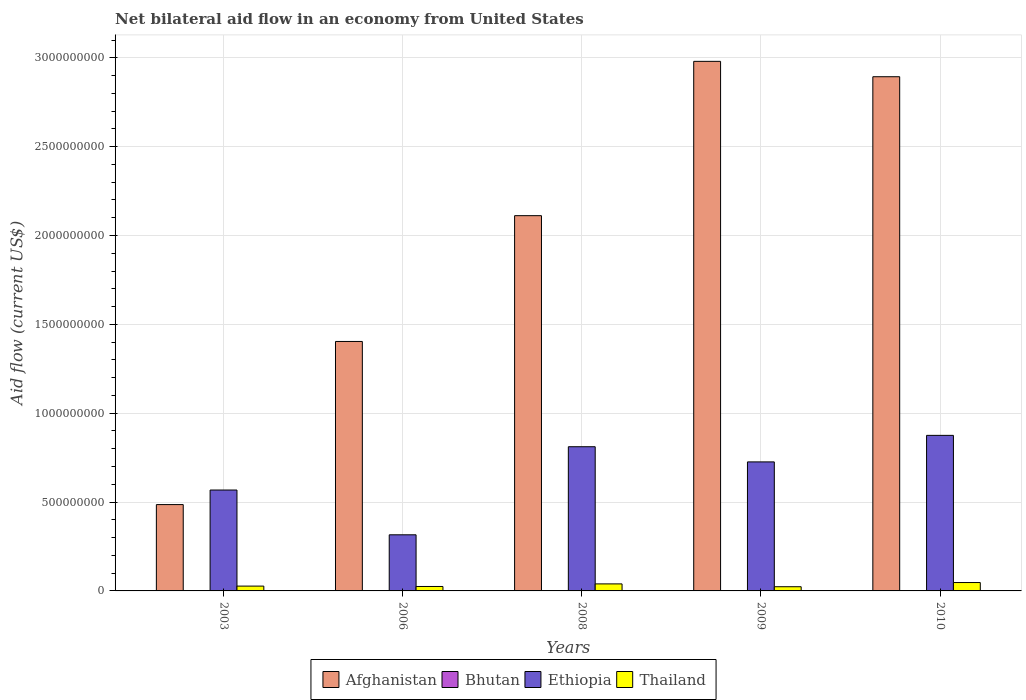How many groups of bars are there?
Offer a terse response. 5. How many bars are there on the 4th tick from the left?
Give a very brief answer. 4. How many bars are there on the 4th tick from the right?
Your response must be concise. 4. What is the label of the 1st group of bars from the left?
Your response must be concise. 2003. What is the net bilateral aid flow in Thailand in 2006?
Ensure brevity in your answer.  2.50e+07. Across all years, what is the maximum net bilateral aid flow in Ethiopia?
Ensure brevity in your answer.  8.75e+08. Across all years, what is the minimum net bilateral aid flow in Thailand?
Provide a short and direct response. 2.36e+07. In which year was the net bilateral aid flow in Bhutan maximum?
Give a very brief answer. 2003. In which year was the net bilateral aid flow in Ethiopia minimum?
Provide a succinct answer. 2006. What is the total net bilateral aid flow in Bhutan in the graph?
Ensure brevity in your answer.  2.17e+06. What is the difference between the net bilateral aid flow in Thailand in 2006 and that in 2009?
Provide a succinct answer. 1.37e+06. What is the difference between the net bilateral aid flow in Ethiopia in 2008 and the net bilateral aid flow in Afghanistan in 2006?
Give a very brief answer. -5.92e+08. What is the average net bilateral aid flow in Bhutan per year?
Your answer should be compact. 4.34e+05. In the year 2006, what is the difference between the net bilateral aid flow in Bhutan and net bilateral aid flow in Thailand?
Ensure brevity in your answer.  -2.49e+07. What is the ratio of the net bilateral aid flow in Thailand in 2006 to that in 2010?
Offer a terse response. 0.53. Is the net bilateral aid flow in Afghanistan in 2003 less than that in 2008?
Make the answer very short. Yes. What is the difference between the highest and the second highest net bilateral aid flow in Thailand?
Your response must be concise. 7.59e+06. What is the difference between the highest and the lowest net bilateral aid flow in Thailand?
Make the answer very short. 2.36e+07. Is it the case that in every year, the sum of the net bilateral aid flow in Bhutan and net bilateral aid flow in Afghanistan is greater than the sum of net bilateral aid flow in Thailand and net bilateral aid flow in Ethiopia?
Offer a very short reply. Yes. What does the 3rd bar from the left in 2006 represents?
Your response must be concise. Ethiopia. What does the 4th bar from the right in 2006 represents?
Keep it short and to the point. Afghanistan. How many bars are there?
Ensure brevity in your answer.  20. What is the difference between two consecutive major ticks on the Y-axis?
Make the answer very short. 5.00e+08. Are the values on the major ticks of Y-axis written in scientific E-notation?
Provide a succinct answer. No. Does the graph contain any zero values?
Give a very brief answer. No. How many legend labels are there?
Keep it short and to the point. 4. How are the legend labels stacked?
Your answer should be compact. Horizontal. What is the title of the graph?
Your answer should be compact. Net bilateral aid flow in an economy from United States. Does "Mexico" appear as one of the legend labels in the graph?
Give a very brief answer. No. What is the label or title of the X-axis?
Provide a succinct answer. Years. What is the Aid flow (current US$) of Afghanistan in 2003?
Offer a terse response. 4.86e+08. What is the Aid flow (current US$) of Bhutan in 2003?
Ensure brevity in your answer.  1.22e+06. What is the Aid flow (current US$) of Ethiopia in 2003?
Give a very brief answer. 5.68e+08. What is the Aid flow (current US$) of Thailand in 2003?
Your answer should be compact. 2.71e+07. What is the Aid flow (current US$) of Afghanistan in 2006?
Your answer should be very brief. 1.40e+09. What is the Aid flow (current US$) in Ethiopia in 2006?
Your answer should be compact. 3.16e+08. What is the Aid flow (current US$) in Thailand in 2006?
Provide a short and direct response. 2.50e+07. What is the Aid flow (current US$) in Afghanistan in 2008?
Offer a very short reply. 2.11e+09. What is the Aid flow (current US$) in Bhutan in 2008?
Keep it short and to the point. 2.40e+05. What is the Aid flow (current US$) of Ethiopia in 2008?
Your answer should be very brief. 8.11e+08. What is the Aid flow (current US$) of Thailand in 2008?
Keep it short and to the point. 3.96e+07. What is the Aid flow (current US$) in Afghanistan in 2009?
Provide a succinct answer. 2.98e+09. What is the Aid flow (current US$) of Ethiopia in 2009?
Your answer should be compact. 7.26e+08. What is the Aid flow (current US$) in Thailand in 2009?
Offer a terse response. 2.36e+07. What is the Aid flow (current US$) of Afghanistan in 2010?
Your answer should be very brief. 2.89e+09. What is the Aid flow (current US$) of Bhutan in 2010?
Ensure brevity in your answer.  6.20e+05. What is the Aid flow (current US$) in Ethiopia in 2010?
Provide a short and direct response. 8.75e+08. What is the Aid flow (current US$) in Thailand in 2010?
Your answer should be very brief. 4.72e+07. Across all years, what is the maximum Aid flow (current US$) of Afghanistan?
Give a very brief answer. 2.98e+09. Across all years, what is the maximum Aid flow (current US$) of Bhutan?
Make the answer very short. 1.22e+06. Across all years, what is the maximum Aid flow (current US$) of Ethiopia?
Make the answer very short. 8.75e+08. Across all years, what is the maximum Aid flow (current US$) of Thailand?
Offer a terse response. 4.72e+07. Across all years, what is the minimum Aid flow (current US$) in Afghanistan?
Your answer should be very brief. 4.86e+08. Across all years, what is the minimum Aid flow (current US$) of Ethiopia?
Your answer should be compact. 3.16e+08. Across all years, what is the minimum Aid flow (current US$) of Thailand?
Offer a terse response. 2.36e+07. What is the total Aid flow (current US$) in Afghanistan in the graph?
Make the answer very short. 9.87e+09. What is the total Aid flow (current US$) in Bhutan in the graph?
Keep it short and to the point. 2.17e+06. What is the total Aid flow (current US$) of Ethiopia in the graph?
Provide a short and direct response. 3.30e+09. What is the total Aid flow (current US$) of Thailand in the graph?
Your answer should be compact. 1.62e+08. What is the difference between the Aid flow (current US$) in Afghanistan in 2003 and that in 2006?
Provide a short and direct response. -9.18e+08. What is the difference between the Aid flow (current US$) of Bhutan in 2003 and that in 2006?
Provide a succinct answer. 1.14e+06. What is the difference between the Aid flow (current US$) in Ethiopia in 2003 and that in 2006?
Provide a short and direct response. 2.52e+08. What is the difference between the Aid flow (current US$) of Thailand in 2003 and that in 2006?
Provide a short and direct response. 2.13e+06. What is the difference between the Aid flow (current US$) of Afghanistan in 2003 and that in 2008?
Ensure brevity in your answer.  -1.63e+09. What is the difference between the Aid flow (current US$) in Bhutan in 2003 and that in 2008?
Make the answer very short. 9.80e+05. What is the difference between the Aid flow (current US$) in Ethiopia in 2003 and that in 2008?
Keep it short and to the point. -2.44e+08. What is the difference between the Aid flow (current US$) in Thailand in 2003 and that in 2008?
Give a very brief answer. -1.25e+07. What is the difference between the Aid flow (current US$) of Afghanistan in 2003 and that in 2009?
Make the answer very short. -2.49e+09. What is the difference between the Aid flow (current US$) in Bhutan in 2003 and that in 2009?
Make the answer very short. 1.21e+06. What is the difference between the Aid flow (current US$) of Ethiopia in 2003 and that in 2009?
Make the answer very short. -1.58e+08. What is the difference between the Aid flow (current US$) in Thailand in 2003 and that in 2009?
Your answer should be very brief. 3.50e+06. What is the difference between the Aid flow (current US$) in Afghanistan in 2003 and that in 2010?
Your response must be concise. -2.41e+09. What is the difference between the Aid flow (current US$) of Ethiopia in 2003 and that in 2010?
Make the answer very short. -3.08e+08. What is the difference between the Aid flow (current US$) of Thailand in 2003 and that in 2010?
Give a very brief answer. -2.00e+07. What is the difference between the Aid flow (current US$) of Afghanistan in 2006 and that in 2008?
Your response must be concise. -7.08e+08. What is the difference between the Aid flow (current US$) of Bhutan in 2006 and that in 2008?
Give a very brief answer. -1.60e+05. What is the difference between the Aid flow (current US$) of Ethiopia in 2006 and that in 2008?
Give a very brief answer. -4.96e+08. What is the difference between the Aid flow (current US$) in Thailand in 2006 and that in 2008?
Offer a terse response. -1.46e+07. What is the difference between the Aid flow (current US$) of Afghanistan in 2006 and that in 2009?
Offer a very short reply. -1.58e+09. What is the difference between the Aid flow (current US$) of Ethiopia in 2006 and that in 2009?
Provide a succinct answer. -4.10e+08. What is the difference between the Aid flow (current US$) in Thailand in 2006 and that in 2009?
Keep it short and to the point. 1.37e+06. What is the difference between the Aid flow (current US$) in Afghanistan in 2006 and that in 2010?
Offer a very short reply. -1.49e+09. What is the difference between the Aid flow (current US$) of Bhutan in 2006 and that in 2010?
Keep it short and to the point. -5.40e+05. What is the difference between the Aid flow (current US$) in Ethiopia in 2006 and that in 2010?
Your answer should be compact. -5.60e+08. What is the difference between the Aid flow (current US$) of Thailand in 2006 and that in 2010?
Make the answer very short. -2.22e+07. What is the difference between the Aid flow (current US$) in Afghanistan in 2008 and that in 2009?
Your response must be concise. -8.68e+08. What is the difference between the Aid flow (current US$) in Bhutan in 2008 and that in 2009?
Ensure brevity in your answer.  2.30e+05. What is the difference between the Aid flow (current US$) of Ethiopia in 2008 and that in 2009?
Make the answer very short. 8.53e+07. What is the difference between the Aid flow (current US$) in Thailand in 2008 and that in 2009?
Provide a short and direct response. 1.60e+07. What is the difference between the Aid flow (current US$) of Afghanistan in 2008 and that in 2010?
Provide a short and direct response. -7.82e+08. What is the difference between the Aid flow (current US$) in Bhutan in 2008 and that in 2010?
Provide a succinct answer. -3.80e+05. What is the difference between the Aid flow (current US$) in Ethiopia in 2008 and that in 2010?
Give a very brief answer. -6.40e+07. What is the difference between the Aid flow (current US$) of Thailand in 2008 and that in 2010?
Your response must be concise. -7.59e+06. What is the difference between the Aid flow (current US$) of Afghanistan in 2009 and that in 2010?
Offer a terse response. 8.65e+07. What is the difference between the Aid flow (current US$) in Bhutan in 2009 and that in 2010?
Keep it short and to the point. -6.10e+05. What is the difference between the Aid flow (current US$) in Ethiopia in 2009 and that in 2010?
Offer a terse response. -1.49e+08. What is the difference between the Aid flow (current US$) in Thailand in 2009 and that in 2010?
Provide a succinct answer. -2.36e+07. What is the difference between the Aid flow (current US$) in Afghanistan in 2003 and the Aid flow (current US$) in Bhutan in 2006?
Provide a short and direct response. 4.86e+08. What is the difference between the Aid flow (current US$) in Afghanistan in 2003 and the Aid flow (current US$) in Ethiopia in 2006?
Your response must be concise. 1.70e+08. What is the difference between the Aid flow (current US$) in Afghanistan in 2003 and the Aid flow (current US$) in Thailand in 2006?
Keep it short and to the point. 4.61e+08. What is the difference between the Aid flow (current US$) of Bhutan in 2003 and the Aid flow (current US$) of Ethiopia in 2006?
Keep it short and to the point. -3.15e+08. What is the difference between the Aid flow (current US$) of Bhutan in 2003 and the Aid flow (current US$) of Thailand in 2006?
Keep it short and to the point. -2.38e+07. What is the difference between the Aid flow (current US$) of Ethiopia in 2003 and the Aid flow (current US$) of Thailand in 2006?
Your answer should be very brief. 5.43e+08. What is the difference between the Aid flow (current US$) of Afghanistan in 2003 and the Aid flow (current US$) of Bhutan in 2008?
Your answer should be very brief. 4.86e+08. What is the difference between the Aid flow (current US$) of Afghanistan in 2003 and the Aid flow (current US$) of Ethiopia in 2008?
Your answer should be very brief. -3.26e+08. What is the difference between the Aid flow (current US$) of Afghanistan in 2003 and the Aid flow (current US$) of Thailand in 2008?
Make the answer very short. 4.46e+08. What is the difference between the Aid flow (current US$) of Bhutan in 2003 and the Aid flow (current US$) of Ethiopia in 2008?
Offer a very short reply. -8.10e+08. What is the difference between the Aid flow (current US$) of Bhutan in 2003 and the Aid flow (current US$) of Thailand in 2008?
Make the answer very short. -3.83e+07. What is the difference between the Aid flow (current US$) in Ethiopia in 2003 and the Aid flow (current US$) in Thailand in 2008?
Give a very brief answer. 5.28e+08. What is the difference between the Aid flow (current US$) of Afghanistan in 2003 and the Aid flow (current US$) of Bhutan in 2009?
Provide a succinct answer. 4.86e+08. What is the difference between the Aid flow (current US$) of Afghanistan in 2003 and the Aid flow (current US$) of Ethiopia in 2009?
Ensure brevity in your answer.  -2.40e+08. What is the difference between the Aid flow (current US$) in Afghanistan in 2003 and the Aid flow (current US$) in Thailand in 2009?
Offer a terse response. 4.62e+08. What is the difference between the Aid flow (current US$) in Bhutan in 2003 and the Aid flow (current US$) in Ethiopia in 2009?
Provide a short and direct response. -7.25e+08. What is the difference between the Aid flow (current US$) in Bhutan in 2003 and the Aid flow (current US$) in Thailand in 2009?
Make the answer very short. -2.24e+07. What is the difference between the Aid flow (current US$) of Ethiopia in 2003 and the Aid flow (current US$) of Thailand in 2009?
Provide a short and direct response. 5.44e+08. What is the difference between the Aid flow (current US$) in Afghanistan in 2003 and the Aid flow (current US$) in Bhutan in 2010?
Ensure brevity in your answer.  4.85e+08. What is the difference between the Aid flow (current US$) in Afghanistan in 2003 and the Aid flow (current US$) in Ethiopia in 2010?
Offer a very short reply. -3.90e+08. What is the difference between the Aid flow (current US$) in Afghanistan in 2003 and the Aid flow (current US$) in Thailand in 2010?
Ensure brevity in your answer.  4.39e+08. What is the difference between the Aid flow (current US$) in Bhutan in 2003 and the Aid flow (current US$) in Ethiopia in 2010?
Keep it short and to the point. -8.74e+08. What is the difference between the Aid flow (current US$) of Bhutan in 2003 and the Aid flow (current US$) of Thailand in 2010?
Give a very brief answer. -4.59e+07. What is the difference between the Aid flow (current US$) in Ethiopia in 2003 and the Aid flow (current US$) in Thailand in 2010?
Offer a very short reply. 5.21e+08. What is the difference between the Aid flow (current US$) in Afghanistan in 2006 and the Aid flow (current US$) in Bhutan in 2008?
Make the answer very short. 1.40e+09. What is the difference between the Aid flow (current US$) in Afghanistan in 2006 and the Aid flow (current US$) in Ethiopia in 2008?
Your answer should be compact. 5.92e+08. What is the difference between the Aid flow (current US$) in Afghanistan in 2006 and the Aid flow (current US$) in Thailand in 2008?
Provide a short and direct response. 1.36e+09. What is the difference between the Aid flow (current US$) of Bhutan in 2006 and the Aid flow (current US$) of Ethiopia in 2008?
Provide a short and direct response. -8.11e+08. What is the difference between the Aid flow (current US$) of Bhutan in 2006 and the Aid flow (current US$) of Thailand in 2008?
Ensure brevity in your answer.  -3.95e+07. What is the difference between the Aid flow (current US$) in Ethiopia in 2006 and the Aid flow (current US$) in Thailand in 2008?
Ensure brevity in your answer.  2.76e+08. What is the difference between the Aid flow (current US$) in Afghanistan in 2006 and the Aid flow (current US$) in Bhutan in 2009?
Provide a short and direct response. 1.40e+09. What is the difference between the Aid flow (current US$) of Afghanistan in 2006 and the Aid flow (current US$) of Ethiopia in 2009?
Offer a very short reply. 6.78e+08. What is the difference between the Aid flow (current US$) in Afghanistan in 2006 and the Aid flow (current US$) in Thailand in 2009?
Ensure brevity in your answer.  1.38e+09. What is the difference between the Aid flow (current US$) in Bhutan in 2006 and the Aid flow (current US$) in Ethiopia in 2009?
Keep it short and to the point. -7.26e+08. What is the difference between the Aid flow (current US$) of Bhutan in 2006 and the Aid flow (current US$) of Thailand in 2009?
Provide a succinct answer. -2.35e+07. What is the difference between the Aid flow (current US$) in Ethiopia in 2006 and the Aid flow (current US$) in Thailand in 2009?
Offer a very short reply. 2.92e+08. What is the difference between the Aid flow (current US$) in Afghanistan in 2006 and the Aid flow (current US$) in Bhutan in 2010?
Give a very brief answer. 1.40e+09. What is the difference between the Aid flow (current US$) in Afghanistan in 2006 and the Aid flow (current US$) in Ethiopia in 2010?
Make the answer very short. 5.28e+08. What is the difference between the Aid flow (current US$) in Afghanistan in 2006 and the Aid flow (current US$) in Thailand in 2010?
Your answer should be very brief. 1.36e+09. What is the difference between the Aid flow (current US$) of Bhutan in 2006 and the Aid flow (current US$) of Ethiopia in 2010?
Make the answer very short. -8.75e+08. What is the difference between the Aid flow (current US$) of Bhutan in 2006 and the Aid flow (current US$) of Thailand in 2010?
Ensure brevity in your answer.  -4.71e+07. What is the difference between the Aid flow (current US$) of Ethiopia in 2006 and the Aid flow (current US$) of Thailand in 2010?
Keep it short and to the point. 2.69e+08. What is the difference between the Aid flow (current US$) of Afghanistan in 2008 and the Aid flow (current US$) of Bhutan in 2009?
Your response must be concise. 2.11e+09. What is the difference between the Aid flow (current US$) in Afghanistan in 2008 and the Aid flow (current US$) in Ethiopia in 2009?
Offer a terse response. 1.39e+09. What is the difference between the Aid flow (current US$) of Afghanistan in 2008 and the Aid flow (current US$) of Thailand in 2009?
Give a very brief answer. 2.09e+09. What is the difference between the Aid flow (current US$) in Bhutan in 2008 and the Aid flow (current US$) in Ethiopia in 2009?
Make the answer very short. -7.26e+08. What is the difference between the Aid flow (current US$) in Bhutan in 2008 and the Aid flow (current US$) in Thailand in 2009?
Give a very brief answer. -2.34e+07. What is the difference between the Aid flow (current US$) of Ethiopia in 2008 and the Aid flow (current US$) of Thailand in 2009?
Make the answer very short. 7.88e+08. What is the difference between the Aid flow (current US$) in Afghanistan in 2008 and the Aid flow (current US$) in Bhutan in 2010?
Make the answer very short. 2.11e+09. What is the difference between the Aid flow (current US$) in Afghanistan in 2008 and the Aid flow (current US$) in Ethiopia in 2010?
Offer a very short reply. 1.24e+09. What is the difference between the Aid flow (current US$) of Afghanistan in 2008 and the Aid flow (current US$) of Thailand in 2010?
Offer a terse response. 2.06e+09. What is the difference between the Aid flow (current US$) of Bhutan in 2008 and the Aid flow (current US$) of Ethiopia in 2010?
Offer a terse response. -8.75e+08. What is the difference between the Aid flow (current US$) of Bhutan in 2008 and the Aid flow (current US$) of Thailand in 2010?
Your answer should be compact. -4.69e+07. What is the difference between the Aid flow (current US$) in Ethiopia in 2008 and the Aid flow (current US$) in Thailand in 2010?
Offer a terse response. 7.64e+08. What is the difference between the Aid flow (current US$) in Afghanistan in 2009 and the Aid flow (current US$) in Bhutan in 2010?
Your answer should be very brief. 2.98e+09. What is the difference between the Aid flow (current US$) of Afghanistan in 2009 and the Aid flow (current US$) of Ethiopia in 2010?
Make the answer very short. 2.10e+09. What is the difference between the Aid flow (current US$) of Afghanistan in 2009 and the Aid flow (current US$) of Thailand in 2010?
Your answer should be compact. 2.93e+09. What is the difference between the Aid flow (current US$) of Bhutan in 2009 and the Aid flow (current US$) of Ethiopia in 2010?
Offer a terse response. -8.75e+08. What is the difference between the Aid flow (current US$) in Bhutan in 2009 and the Aid flow (current US$) in Thailand in 2010?
Offer a very short reply. -4.71e+07. What is the difference between the Aid flow (current US$) of Ethiopia in 2009 and the Aid flow (current US$) of Thailand in 2010?
Your answer should be compact. 6.79e+08. What is the average Aid flow (current US$) in Afghanistan per year?
Make the answer very short. 1.97e+09. What is the average Aid flow (current US$) in Bhutan per year?
Provide a short and direct response. 4.34e+05. What is the average Aid flow (current US$) in Ethiopia per year?
Your response must be concise. 6.59e+08. What is the average Aid flow (current US$) in Thailand per year?
Offer a terse response. 3.25e+07. In the year 2003, what is the difference between the Aid flow (current US$) of Afghanistan and Aid flow (current US$) of Bhutan?
Make the answer very short. 4.85e+08. In the year 2003, what is the difference between the Aid flow (current US$) in Afghanistan and Aid flow (current US$) in Ethiopia?
Your answer should be very brief. -8.20e+07. In the year 2003, what is the difference between the Aid flow (current US$) in Afghanistan and Aid flow (current US$) in Thailand?
Provide a short and direct response. 4.59e+08. In the year 2003, what is the difference between the Aid flow (current US$) in Bhutan and Aid flow (current US$) in Ethiopia?
Your answer should be compact. -5.67e+08. In the year 2003, what is the difference between the Aid flow (current US$) in Bhutan and Aid flow (current US$) in Thailand?
Your response must be concise. -2.59e+07. In the year 2003, what is the difference between the Aid flow (current US$) in Ethiopia and Aid flow (current US$) in Thailand?
Your answer should be very brief. 5.41e+08. In the year 2006, what is the difference between the Aid flow (current US$) in Afghanistan and Aid flow (current US$) in Bhutan?
Keep it short and to the point. 1.40e+09. In the year 2006, what is the difference between the Aid flow (current US$) in Afghanistan and Aid flow (current US$) in Ethiopia?
Give a very brief answer. 1.09e+09. In the year 2006, what is the difference between the Aid flow (current US$) of Afghanistan and Aid flow (current US$) of Thailand?
Provide a succinct answer. 1.38e+09. In the year 2006, what is the difference between the Aid flow (current US$) of Bhutan and Aid flow (current US$) of Ethiopia?
Offer a very short reply. -3.16e+08. In the year 2006, what is the difference between the Aid flow (current US$) in Bhutan and Aid flow (current US$) in Thailand?
Provide a short and direct response. -2.49e+07. In the year 2006, what is the difference between the Aid flow (current US$) of Ethiopia and Aid flow (current US$) of Thailand?
Make the answer very short. 2.91e+08. In the year 2008, what is the difference between the Aid flow (current US$) in Afghanistan and Aid flow (current US$) in Bhutan?
Make the answer very short. 2.11e+09. In the year 2008, what is the difference between the Aid flow (current US$) in Afghanistan and Aid flow (current US$) in Ethiopia?
Your answer should be very brief. 1.30e+09. In the year 2008, what is the difference between the Aid flow (current US$) in Afghanistan and Aid flow (current US$) in Thailand?
Make the answer very short. 2.07e+09. In the year 2008, what is the difference between the Aid flow (current US$) in Bhutan and Aid flow (current US$) in Ethiopia?
Your answer should be very brief. -8.11e+08. In the year 2008, what is the difference between the Aid flow (current US$) of Bhutan and Aid flow (current US$) of Thailand?
Offer a very short reply. -3.93e+07. In the year 2008, what is the difference between the Aid flow (current US$) in Ethiopia and Aid flow (current US$) in Thailand?
Make the answer very short. 7.72e+08. In the year 2009, what is the difference between the Aid flow (current US$) in Afghanistan and Aid flow (current US$) in Bhutan?
Offer a terse response. 2.98e+09. In the year 2009, what is the difference between the Aid flow (current US$) in Afghanistan and Aid flow (current US$) in Ethiopia?
Provide a short and direct response. 2.25e+09. In the year 2009, what is the difference between the Aid flow (current US$) of Afghanistan and Aid flow (current US$) of Thailand?
Your answer should be very brief. 2.96e+09. In the year 2009, what is the difference between the Aid flow (current US$) of Bhutan and Aid flow (current US$) of Ethiopia?
Your answer should be compact. -7.26e+08. In the year 2009, what is the difference between the Aid flow (current US$) of Bhutan and Aid flow (current US$) of Thailand?
Give a very brief answer. -2.36e+07. In the year 2009, what is the difference between the Aid flow (current US$) in Ethiopia and Aid flow (current US$) in Thailand?
Your answer should be very brief. 7.02e+08. In the year 2010, what is the difference between the Aid flow (current US$) of Afghanistan and Aid flow (current US$) of Bhutan?
Give a very brief answer. 2.89e+09. In the year 2010, what is the difference between the Aid flow (current US$) of Afghanistan and Aid flow (current US$) of Ethiopia?
Your answer should be very brief. 2.02e+09. In the year 2010, what is the difference between the Aid flow (current US$) of Afghanistan and Aid flow (current US$) of Thailand?
Offer a very short reply. 2.85e+09. In the year 2010, what is the difference between the Aid flow (current US$) of Bhutan and Aid flow (current US$) of Ethiopia?
Offer a very short reply. -8.75e+08. In the year 2010, what is the difference between the Aid flow (current US$) of Bhutan and Aid flow (current US$) of Thailand?
Make the answer very short. -4.65e+07. In the year 2010, what is the difference between the Aid flow (current US$) in Ethiopia and Aid flow (current US$) in Thailand?
Your answer should be very brief. 8.28e+08. What is the ratio of the Aid flow (current US$) of Afghanistan in 2003 to that in 2006?
Your answer should be very brief. 0.35. What is the ratio of the Aid flow (current US$) of Bhutan in 2003 to that in 2006?
Provide a short and direct response. 15.25. What is the ratio of the Aid flow (current US$) of Ethiopia in 2003 to that in 2006?
Offer a very short reply. 1.8. What is the ratio of the Aid flow (current US$) of Thailand in 2003 to that in 2006?
Ensure brevity in your answer.  1.09. What is the ratio of the Aid flow (current US$) of Afghanistan in 2003 to that in 2008?
Your response must be concise. 0.23. What is the ratio of the Aid flow (current US$) in Bhutan in 2003 to that in 2008?
Your response must be concise. 5.08. What is the ratio of the Aid flow (current US$) in Ethiopia in 2003 to that in 2008?
Keep it short and to the point. 0.7. What is the ratio of the Aid flow (current US$) of Thailand in 2003 to that in 2008?
Your answer should be compact. 0.69. What is the ratio of the Aid flow (current US$) of Afghanistan in 2003 to that in 2009?
Your answer should be very brief. 0.16. What is the ratio of the Aid flow (current US$) of Bhutan in 2003 to that in 2009?
Offer a terse response. 122. What is the ratio of the Aid flow (current US$) of Ethiopia in 2003 to that in 2009?
Keep it short and to the point. 0.78. What is the ratio of the Aid flow (current US$) in Thailand in 2003 to that in 2009?
Ensure brevity in your answer.  1.15. What is the ratio of the Aid flow (current US$) of Afghanistan in 2003 to that in 2010?
Offer a terse response. 0.17. What is the ratio of the Aid flow (current US$) in Bhutan in 2003 to that in 2010?
Make the answer very short. 1.97. What is the ratio of the Aid flow (current US$) of Ethiopia in 2003 to that in 2010?
Provide a succinct answer. 0.65. What is the ratio of the Aid flow (current US$) of Thailand in 2003 to that in 2010?
Ensure brevity in your answer.  0.57. What is the ratio of the Aid flow (current US$) of Afghanistan in 2006 to that in 2008?
Offer a very short reply. 0.66. What is the ratio of the Aid flow (current US$) in Ethiopia in 2006 to that in 2008?
Give a very brief answer. 0.39. What is the ratio of the Aid flow (current US$) of Thailand in 2006 to that in 2008?
Your answer should be compact. 0.63. What is the ratio of the Aid flow (current US$) of Afghanistan in 2006 to that in 2009?
Provide a succinct answer. 0.47. What is the ratio of the Aid flow (current US$) in Ethiopia in 2006 to that in 2009?
Your response must be concise. 0.43. What is the ratio of the Aid flow (current US$) in Thailand in 2006 to that in 2009?
Keep it short and to the point. 1.06. What is the ratio of the Aid flow (current US$) of Afghanistan in 2006 to that in 2010?
Your response must be concise. 0.49. What is the ratio of the Aid flow (current US$) in Bhutan in 2006 to that in 2010?
Your response must be concise. 0.13. What is the ratio of the Aid flow (current US$) in Ethiopia in 2006 to that in 2010?
Your answer should be very brief. 0.36. What is the ratio of the Aid flow (current US$) in Thailand in 2006 to that in 2010?
Offer a very short reply. 0.53. What is the ratio of the Aid flow (current US$) of Afghanistan in 2008 to that in 2009?
Give a very brief answer. 0.71. What is the ratio of the Aid flow (current US$) in Ethiopia in 2008 to that in 2009?
Keep it short and to the point. 1.12. What is the ratio of the Aid flow (current US$) in Thailand in 2008 to that in 2009?
Offer a very short reply. 1.68. What is the ratio of the Aid flow (current US$) in Afghanistan in 2008 to that in 2010?
Offer a terse response. 0.73. What is the ratio of the Aid flow (current US$) in Bhutan in 2008 to that in 2010?
Your response must be concise. 0.39. What is the ratio of the Aid flow (current US$) in Ethiopia in 2008 to that in 2010?
Ensure brevity in your answer.  0.93. What is the ratio of the Aid flow (current US$) in Thailand in 2008 to that in 2010?
Your answer should be compact. 0.84. What is the ratio of the Aid flow (current US$) of Afghanistan in 2009 to that in 2010?
Provide a short and direct response. 1.03. What is the ratio of the Aid flow (current US$) in Bhutan in 2009 to that in 2010?
Offer a very short reply. 0.02. What is the ratio of the Aid flow (current US$) in Ethiopia in 2009 to that in 2010?
Ensure brevity in your answer.  0.83. What is the ratio of the Aid flow (current US$) of Thailand in 2009 to that in 2010?
Your answer should be compact. 0.5. What is the difference between the highest and the second highest Aid flow (current US$) of Afghanistan?
Provide a succinct answer. 8.65e+07. What is the difference between the highest and the second highest Aid flow (current US$) of Bhutan?
Provide a succinct answer. 6.00e+05. What is the difference between the highest and the second highest Aid flow (current US$) in Ethiopia?
Ensure brevity in your answer.  6.40e+07. What is the difference between the highest and the second highest Aid flow (current US$) in Thailand?
Offer a terse response. 7.59e+06. What is the difference between the highest and the lowest Aid flow (current US$) of Afghanistan?
Keep it short and to the point. 2.49e+09. What is the difference between the highest and the lowest Aid flow (current US$) of Bhutan?
Make the answer very short. 1.21e+06. What is the difference between the highest and the lowest Aid flow (current US$) of Ethiopia?
Your answer should be very brief. 5.60e+08. What is the difference between the highest and the lowest Aid flow (current US$) of Thailand?
Offer a terse response. 2.36e+07. 